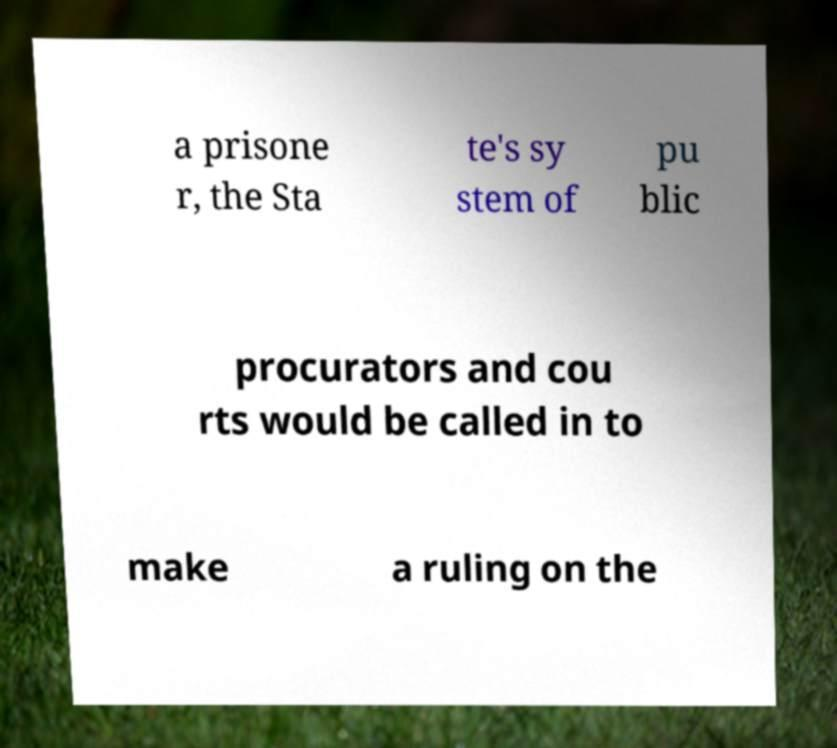For documentation purposes, I need the text within this image transcribed. Could you provide that? a prisone r, the Sta te's sy stem of pu blic procurators and cou rts would be called in to make a ruling on the 